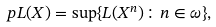<formula> <loc_0><loc_0><loc_500><loc_500>p L ( X ) = \sup \{ L ( X ^ { n } ) \colon n \in \omega \} ,</formula> 